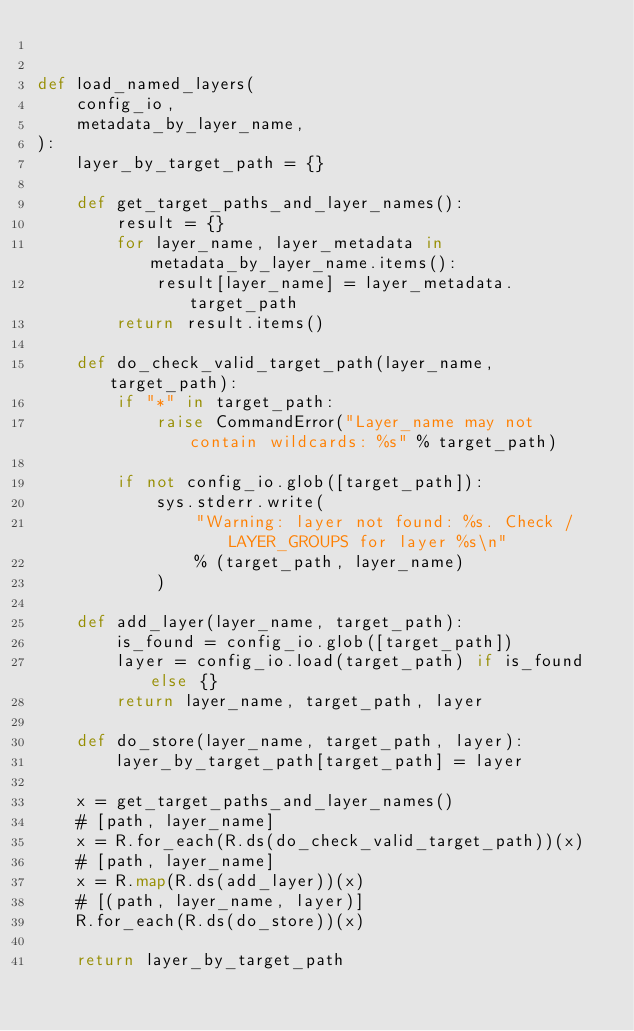Convert code to text. <code><loc_0><loc_0><loc_500><loc_500><_Python_>

def load_named_layers(
    config_io,
    metadata_by_layer_name,
):
    layer_by_target_path = {}

    def get_target_paths_and_layer_names():
        result = {}
        for layer_name, layer_metadata in metadata_by_layer_name.items():
            result[layer_name] = layer_metadata.target_path
        return result.items()

    def do_check_valid_target_path(layer_name, target_path):
        if "*" in target_path:
            raise CommandError("Layer_name may not contain wildcards: %s" % target_path)

        if not config_io.glob([target_path]):
            sys.stderr.write(
                "Warning: layer not found: %s. Check /LAYER_GROUPS for layer %s\n"
                % (target_path, layer_name)
            )

    def add_layer(layer_name, target_path):
        is_found = config_io.glob([target_path])
        layer = config_io.load(target_path) if is_found else {}
        return layer_name, target_path, layer

    def do_store(layer_name, target_path, layer):
        layer_by_target_path[target_path] = layer

    x = get_target_paths_and_layer_names()
    # [path, layer_name]
    x = R.for_each(R.ds(do_check_valid_target_path))(x)
    # [path, layer_name]
    x = R.map(R.ds(add_layer))(x)
    # [(path, layer_name, layer)]
    R.for_each(R.ds(do_store))(x)

    return layer_by_target_path
</code> 